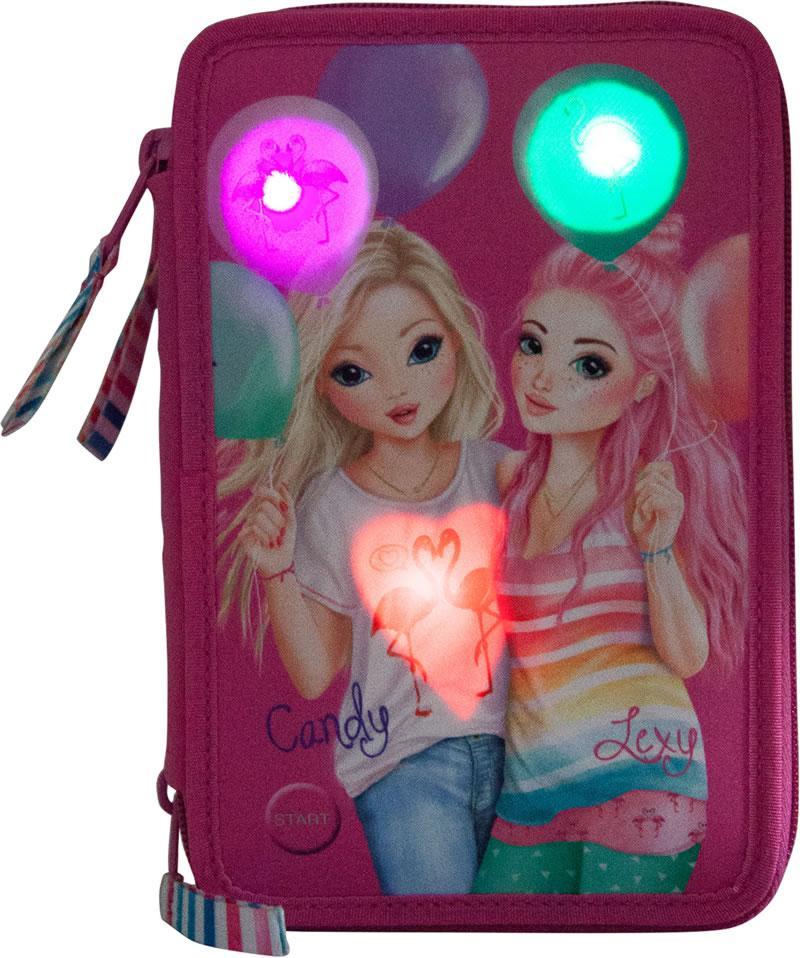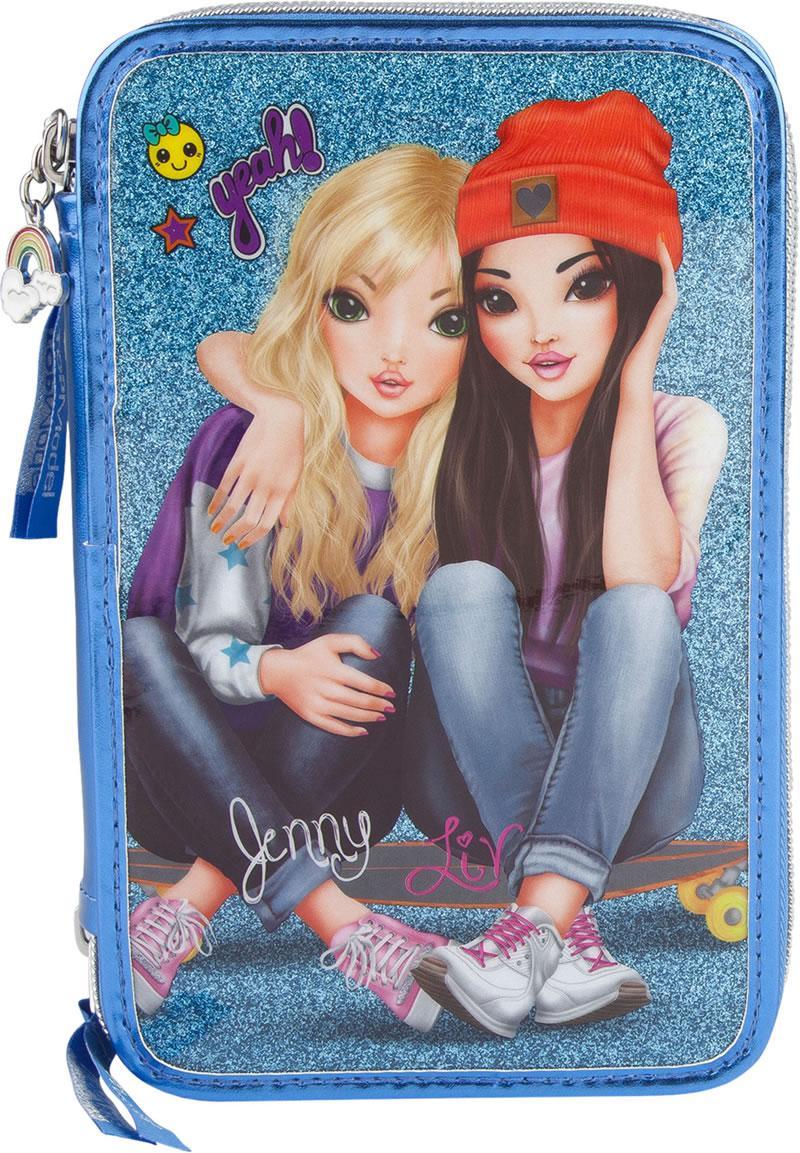The first image is the image on the left, the second image is the image on the right. Given the left and right images, does the statement "There are two zippered wallets." hold true? Answer yes or no. Yes. The first image is the image on the left, the second image is the image on the right. Given the left and right images, does the statement "One of the two images has a bag with the characters from Disney's Frozen on it." hold true? Answer yes or no. No. 